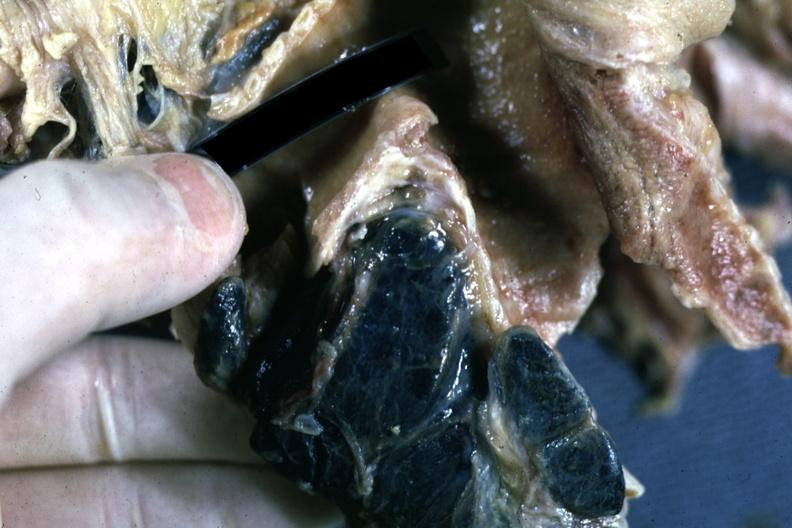what is fixed tissue sectioned?
Answer the question using a single word or phrase. Carinal nodes shown close-up nodes are filled with black pigment 